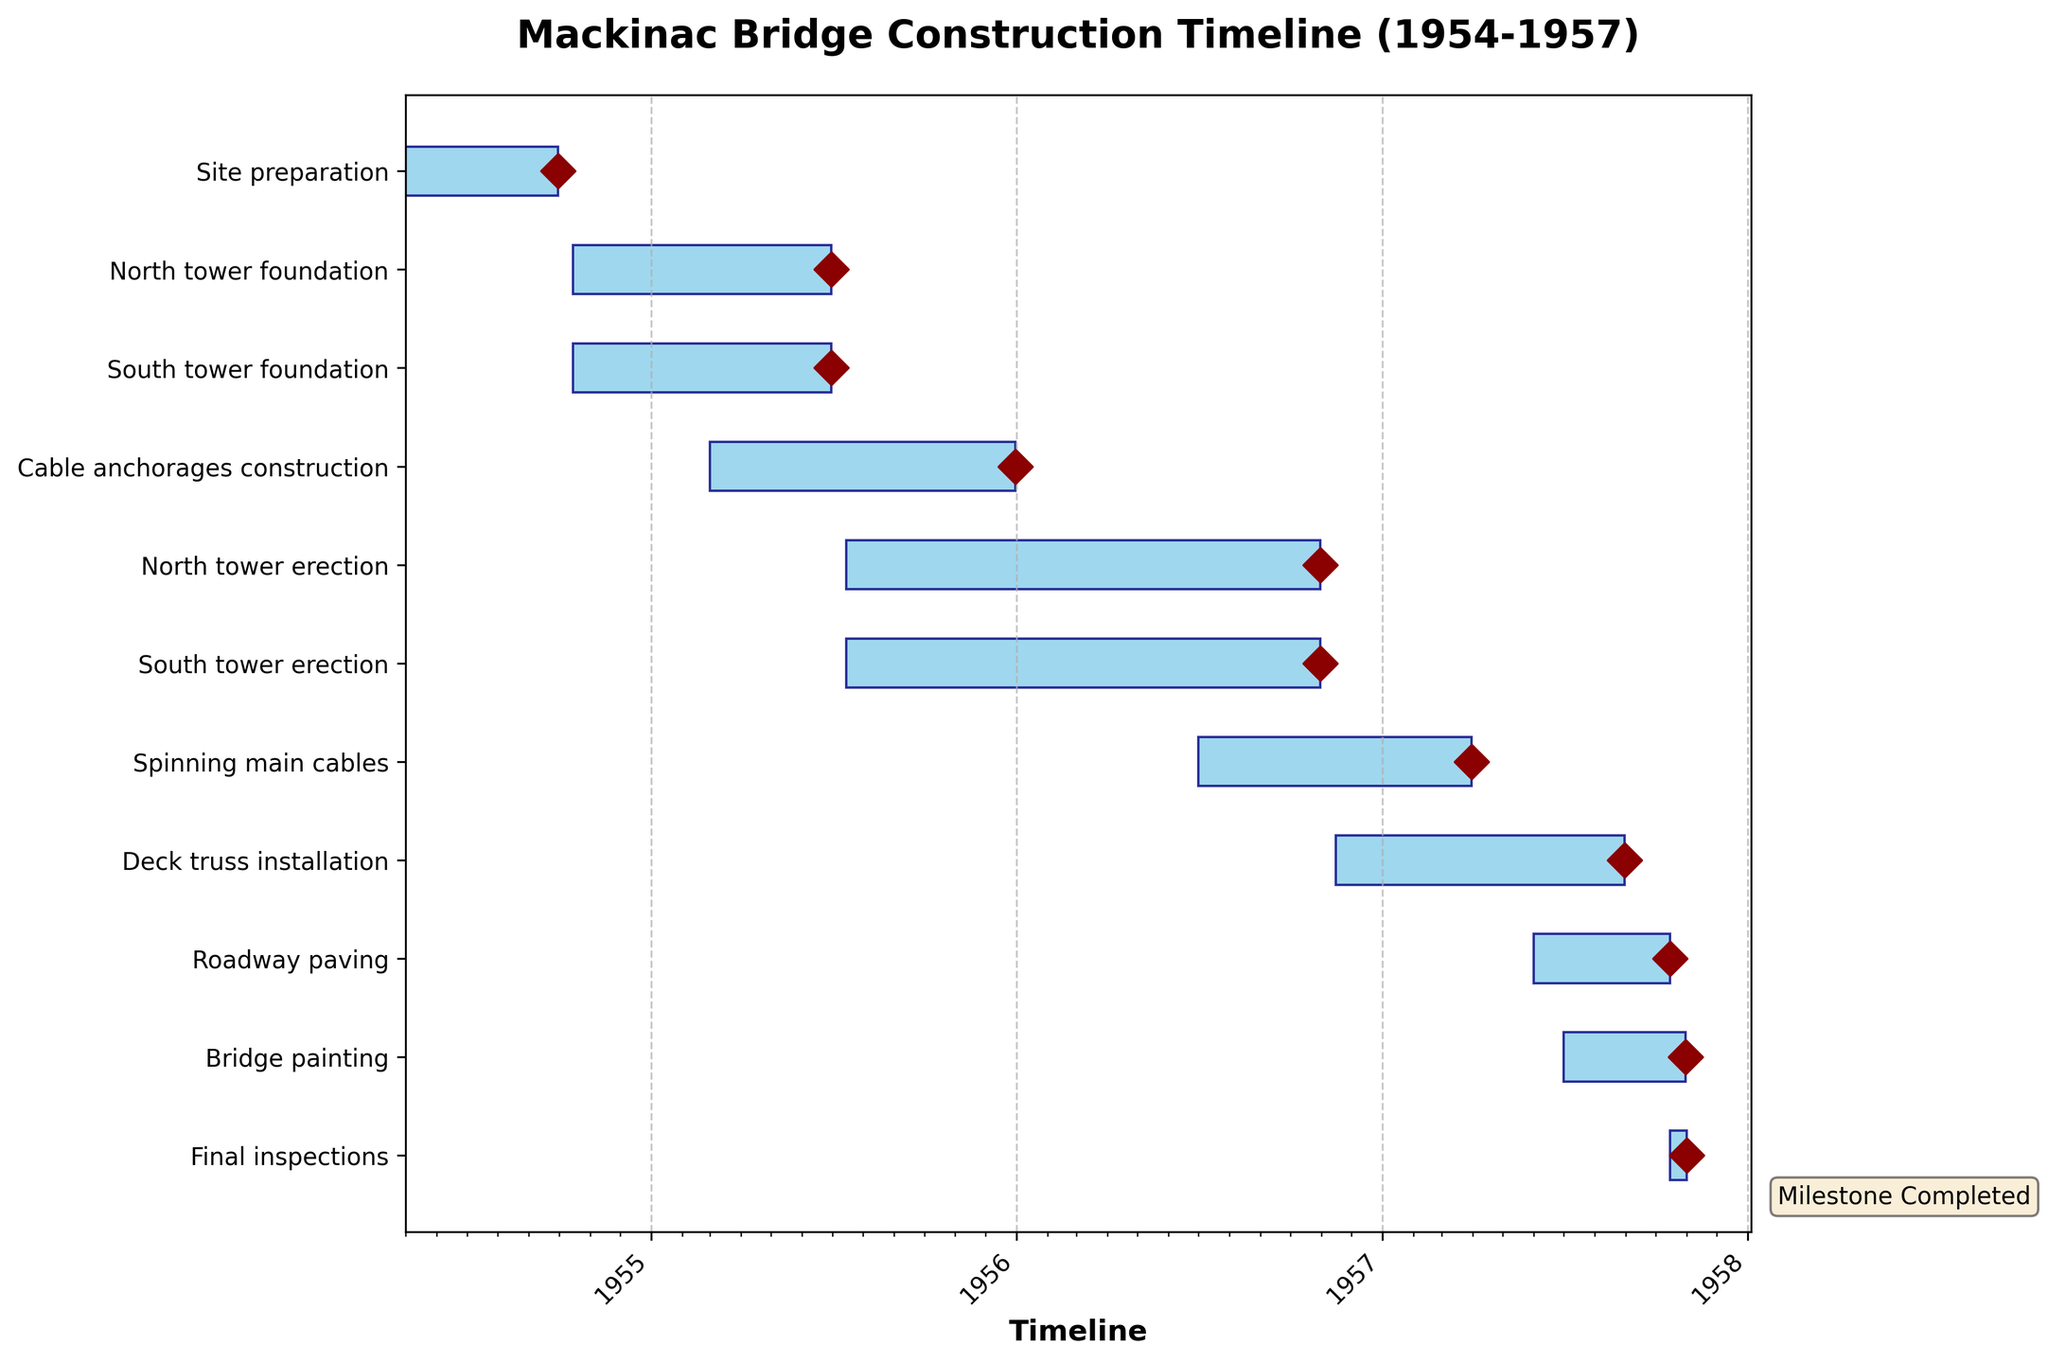What is the title of the chart? The title is usually located at the top of the chart and describes the main topic or focus.
Answer: Mackinac Bridge Construction Timeline (1954-1957) How many total tasks are depicted in the Gantt Chart? Count the number of distinct tasks listed on the y-axis.
Answer: 10 Which task started the earliest? Identify the task with the earliest start date on the timeline.
Answer: Site preparation Which two tasks have the same start and end dates? Look for tasks that have overlapping start and end date ranges.
Answer: North tower foundation and South tower foundation Which task took the longest to complete? Find the task that has the largest horizontal bar length, indicating the longest duration.
Answer: Deck truss installation Between 'South tower erection' and 'North tower erection', which one started first? Compare the start dates of the two tasks directly from the chart.
Answer: Both started at the same time How many tasks were ongoing in July 1956? Identify which tasks are active during July 1956 by seeing their overlap with that date.
Answer: 4 Which task was the last to be completed? Look for the task with the latest end date on the timeline.
Answer: Final inspections What is the combined duration of 'Spinning main cables' and 'Roadway paving'? Sum the durations of 'Spinning main cables' and 'Roadway paving' by adding their timelines up.
Answer: 15.5 months or approximately 474 days Did any tasks overlap with 'Bridge painting'? If so, which ones? Check the tasks' start and end dates to see if they overlap with the duration of 'Bridge painting'.
Answer: Roadway paving and Final inspections 